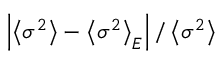Convert formula to latex. <formula><loc_0><loc_0><loc_500><loc_500>\left | \left \langle \sigma ^ { 2 } \right \rangle - \left \langle \sigma ^ { 2 } \right \rangle _ { E } \right | / \left \langle \sigma ^ { 2 } \right \rangle</formula> 